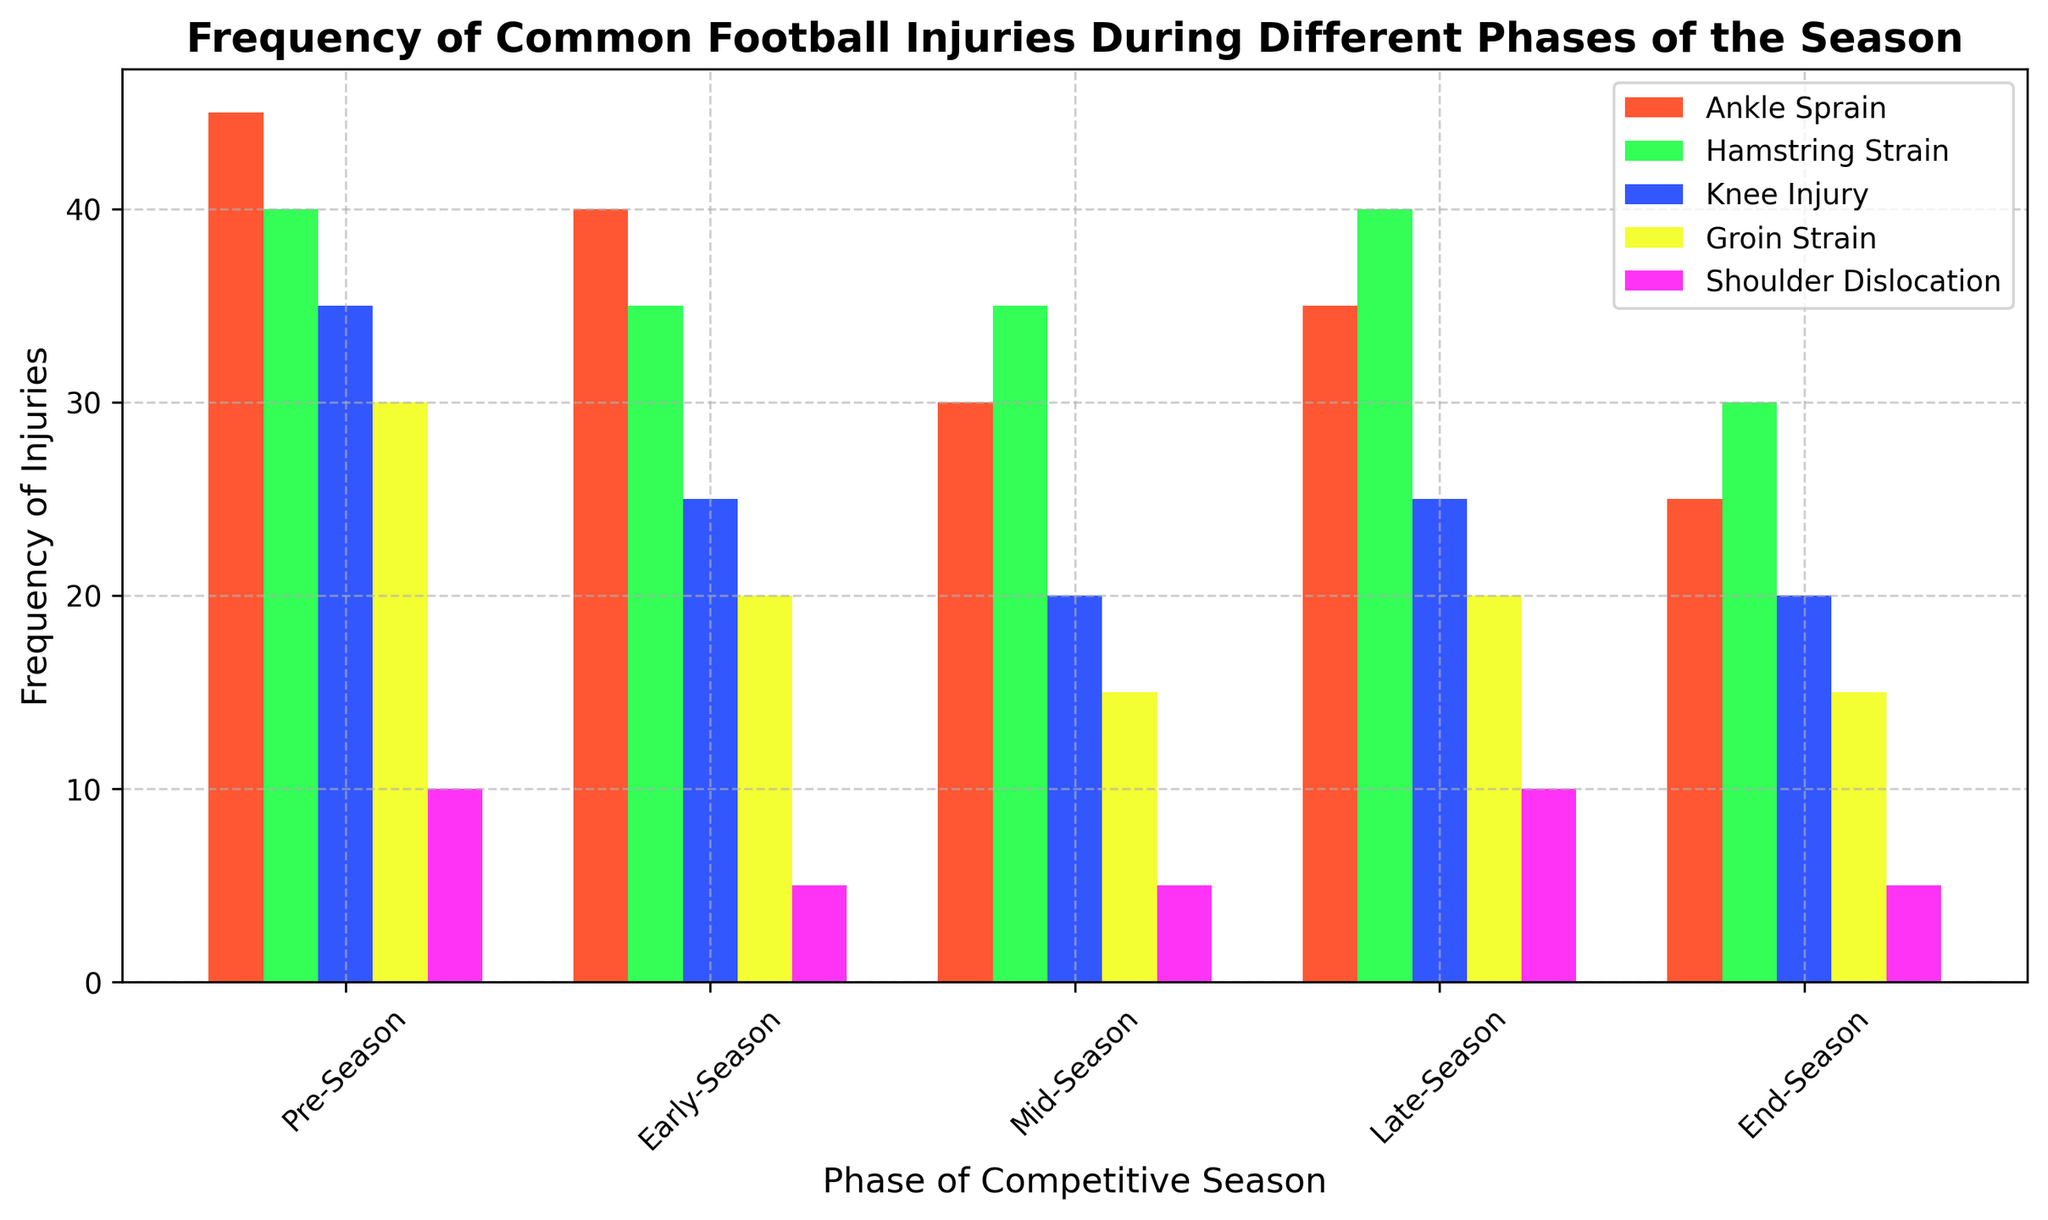What phase has the highest frequency of ankle sprains? Look at the bar representing ankle sprains in each phase. The tallest bar indicates the highest frequency. In this case, the pre-season has the tallest bar for ankle sprains.
Answer: Pre-Season Which injury type has the highest frequency in the late-season phase? Compare the heights of all the bars in the late-season phase. The tallest bar represents the highest frequency injury type. The green bar (Hamstring Strain) is the tallest.
Answer: Hamstring Strain What is the total frequency of knee injuries across all phases? Sum the frequencies of knee injuries from all phases: 35 (Pre-Season) + 25 (Early-Season) + 20 (Mid-Season) + 25 (Late-Season) + 20 (End-Season). The total is 125.
Answer: 125 Is the frequency of shoulder dislocations greater in the pre-season or the mid-season? Compare the heights of the shoulder dislocation bars in the pre-season and mid-season phases. The bar in the pre-season is taller.
Answer: Pre-Season What is the combined frequency of hamstring strains and groin strains in the pre-season? Sum the frequencies of hamstring strain (40) and groin strain (30) in the pre-season: 40 + 30 = 70.
Answer: 70 Does the frequency of ankle sprains increase or decrease from mid-season to late-season? Compare the heights of the ankle sprain bars in the mid-season and late-season phases. The later season bar is taller compared to the mid-season.
Answer: Increase How many injuries have the frequency of exactly 30 during the end-season? Check the heights of bars corresponding to the value of 30 in the end-season phase. Only the green bar (Hamstring Strain) has a height of 30.
Answer: 1 Which phase has the lowest overall frequency of injuries for groin strains? Compare the heights of the groin strain bars across all phases. The end-season has the shortest bar.
Answer: End-Season Is the frequency of shoulder dislocations in the early-season equal to that in the end-season? Compare the heights of the shoulder dislocation bars in the early-season and the end-season. Both bars are at the same height.
Answer: Yes 